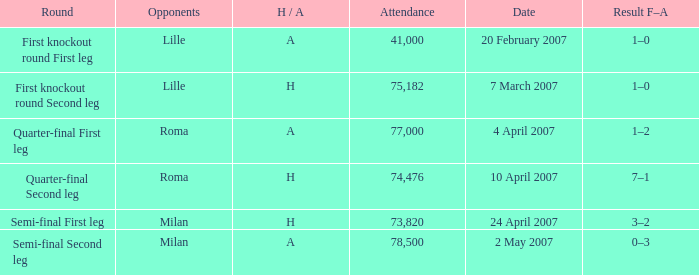Which date has roma as opponent and a H/A of A? 4 April 2007. 